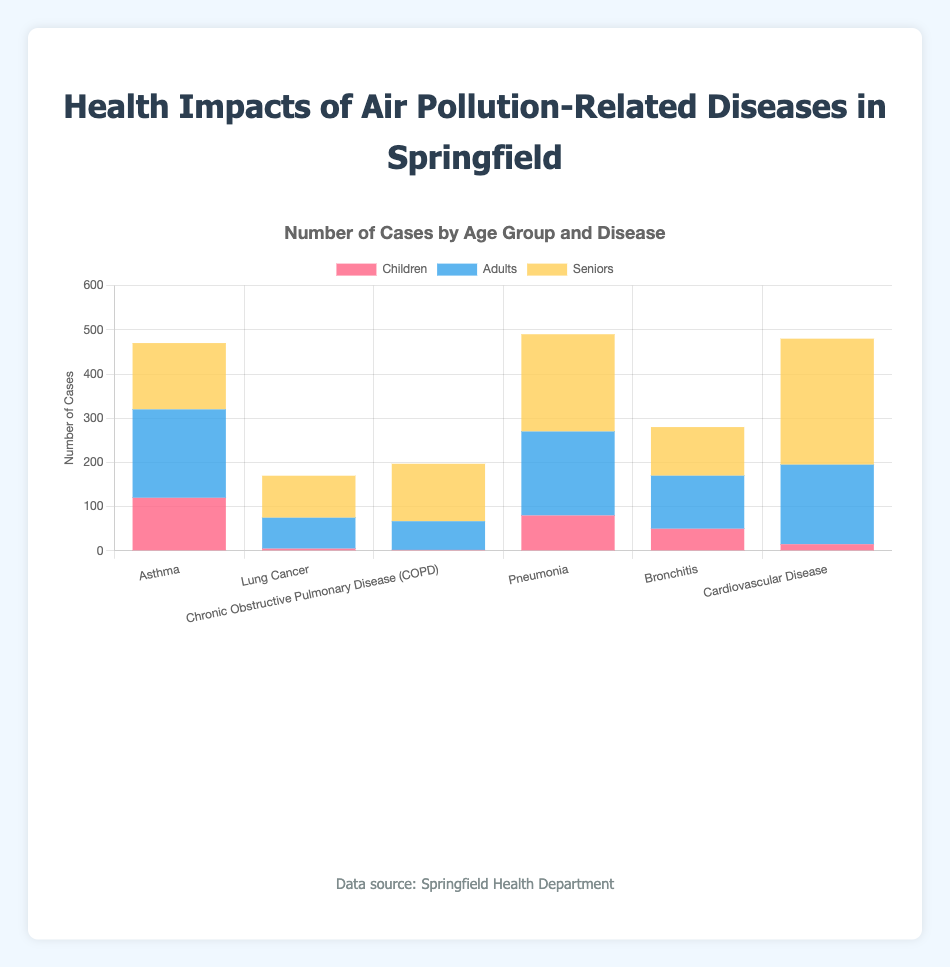What is the total number of Asthma cases across all age groups? Sum the cases for children, adults, and seniors affected by Asthma. That's 120 (children) + 200 (adults) + 150 (seniors).
Answer: 470 Which disease shows the highest number of cases among children? Look at the tallest red bar representing children for each disease. The largest bar is for Asthma with 120 cases.
Answer: Asthma What is the average number of cases of Bronchitis for all age groups? Add the cases for children, adults, and seniors, then divide by the number of groups (3). That's (50 + 120 + 110) / 3.
Answer: 93.33 How does the number of Pneumonia cases in seniors compare to those in adults? Compare the height of the yellow bar (seniors) and the blue bar (adults) for Pneumonia. Seniors have 220 cases and adults have 190 cases.
Answer: Seniors have 30 more cases Which age group has the highest number of Cardiovascular Disease cases? Look for the longest bar in the stack corresponding to Cardiovascular Disease. The longest bar belongs to seniors with 285 cases.
Answer: Seniors What is the total number of cases for diseases related to air pollution among adults? Sum the cases for adults for all diseases. That’s 200 + 70 + 65 + 190 + 120 + 180.
Answer: 825 Which disease has the lowest number of cases for children? Look for the shortest red bar among all the diseases. The shortest bar belongs to Chronic Obstructive Pulmonary Disease (COPD) with 2 cases.
Answer: COPD How many more Asthma cases are there in adults compared to seniors? Find the difference between Asthma cases in adults and seniors. That’s 200 (adults) - 150 (seniors).
Answer: 50 What is the difference in total cases between Pneumonia and Lung Cancer across all age groups? Calculate the total number of cases for Pneumonia and Lung Cancer, then find the difference. Pneumonia: 80 + 190 + 220 = 490, Lung Cancer: 5 + 70 + 95 = 170. The difference is 490 - 170.
Answer: 320 What is the total number of air pollution-related disease cases in seniors? Sum the cases for seniors for all diseases. That’s 150 + 95 + 130 + 220 + 110 + 285.
Answer: 990 